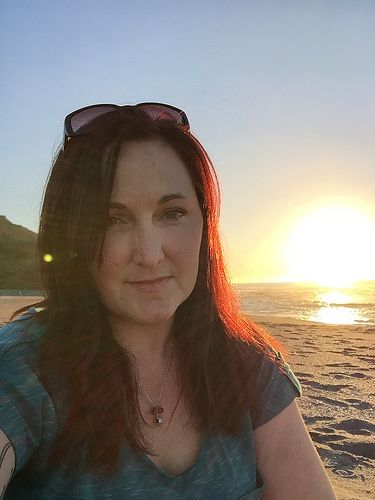<image>
Is the woman behind the montana? No. The woman is not behind the montana. From this viewpoint, the woman appears to be positioned elsewhere in the scene. 